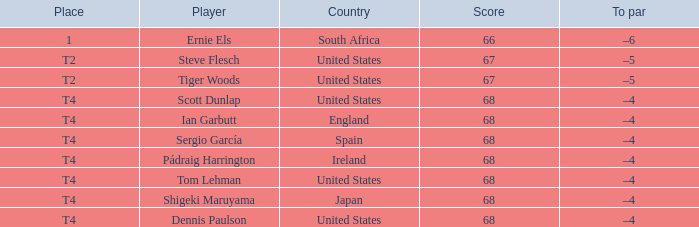What is the Place of the Player with a Score of 67? T2, T2. 